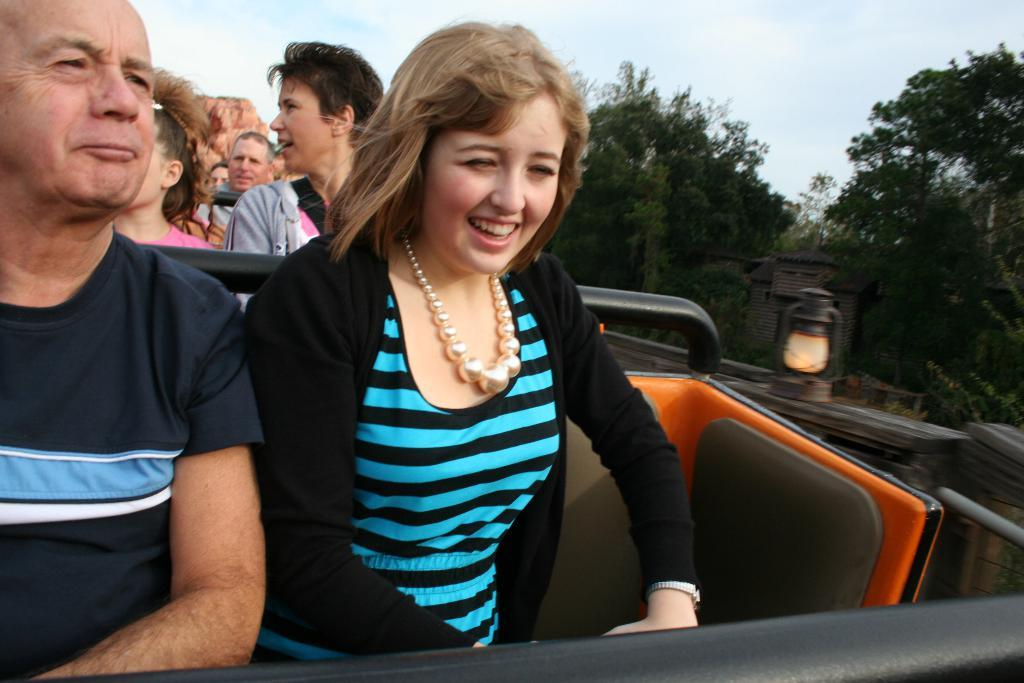What are the people in the image doing? The people in the image are sitting in a vehicle. Can you describe any objects or features inside the vehicle? The provided facts do not mention any specific objects or features inside the vehicle. What can be seen on the right side of the image? There is a lamp placed on the wall on the right side of the image. What is visible in the background of the image? There are trees, a shed, and the sky visible in the background of the image. What type of skin condition can be seen on the people in the image? There is no information about the people's skin conditions in the image. Can you tell me how many dolls are sitting in the vehicle with the people? There are no dolls present in the image; only people are visible in the vehicle. 